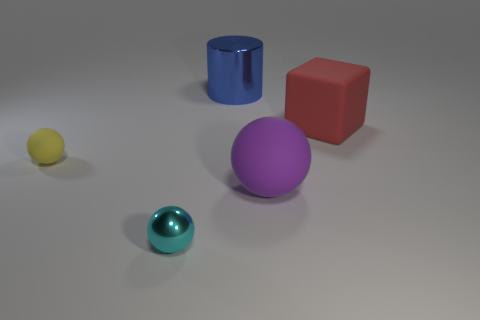Subtract all purple spheres. How many spheres are left? 2 Add 4 metal objects. How many objects exist? 9 Subtract all yellow balls. How many balls are left? 2 Subtract all blocks. How many objects are left? 4 Subtract all brown spheres. Subtract all green cylinders. How many spheres are left? 3 Subtract 1 yellow balls. How many objects are left? 4 Subtract all large red rubber cubes. Subtract all metallic objects. How many objects are left? 2 Add 2 small yellow rubber objects. How many small yellow rubber objects are left? 3 Add 3 purple matte things. How many purple matte things exist? 4 